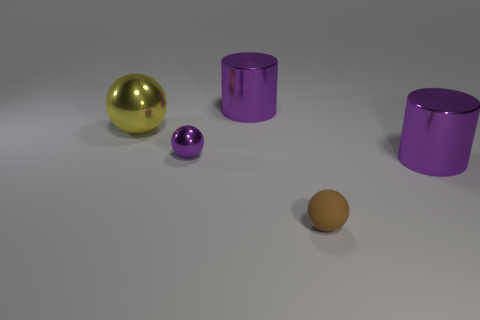What material is the purple sphere that is the same size as the brown thing?
Provide a succinct answer. Metal. What material is the big yellow ball?
Ensure brevity in your answer.  Metal. What is the material of the large thing that is the same shape as the tiny metallic object?
Ensure brevity in your answer.  Metal. Is the big yellow sphere made of the same material as the purple ball?
Your response must be concise. Yes. What is the cylinder that is behind the metal object right of the small brown object made of?
Your response must be concise. Metal. What number of small objects are either balls or metal balls?
Your answer should be compact. 2. What is the size of the yellow shiny thing?
Ensure brevity in your answer.  Large. Is the number of big metallic things that are left of the tiny purple object greater than the number of large cyan shiny balls?
Give a very brief answer. Yes. Are there an equal number of big purple metallic things in front of the small brown rubber sphere and metallic cylinders left of the small purple thing?
Offer a very short reply. Yes. There is a sphere that is both behind the matte ball and to the right of the yellow shiny sphere; what is its color?
Provide a succinct answer. Purple. 